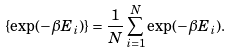Convert formula to latex. <formula><loc_0><loc_0><loc_500><loc_500>\{ \exp ( - \beta E _ { i } ) \} = \frac { 1 } { N } \sum ^ { N } _ { i = 1 } \exp ( - \beta E _ { i } ) .</formula> 